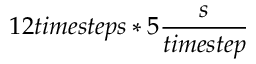Convert formula to latex. <formula><loc_0><loc_0><loc_500><loc_500>1 2 t i m e s t e p s * 5 \frac { s } { t i m e s t e p }</formula> 